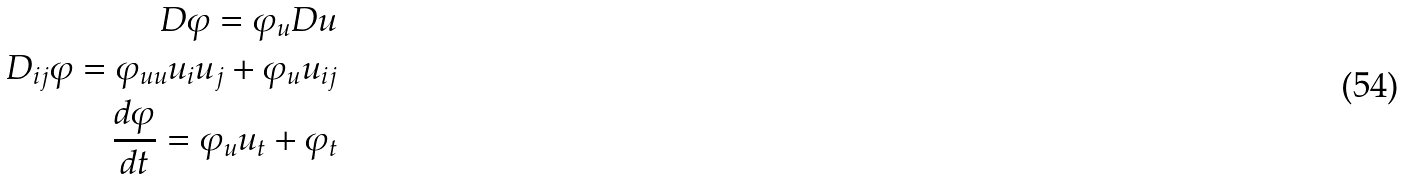<formula> <loc_0><loc_0><loc_500><loc_500>D \varphi = \varphi _ { u } D u \\ D _ { i j } \varphi = \varphi _ { u u } u _ { i } u _ { j } + \varphi _ { u } u _ { i j } \\ \frac { d \varphi } { d t } = \varphi _ { u } u _ { t } + \varphi _ { t }</formula> 